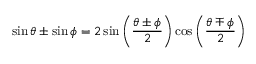<formula> <loc_0><loc_0><loc_500><loc_500>\sin \theta \pm \sin \phi = 2 \sin \left ( { \frac { \theta \pm \phi } { 2 } } \right ) \cos \left ( { \frac { \theta \mp \phi } { 2 } } \right )</formula> 